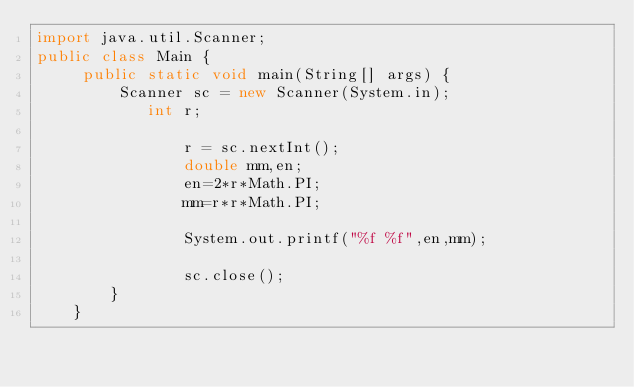<code> <loc_0><loc_0><loc_500><loc_500><_Java_>import java.util.Scanner;
public class Main {
	 public static void main(String[] args) {
		 Scanner sc = new Scanner(System.in);
	        int r;

	            r = sc.nextInt();
	            double mm,en;
	            en=2*r*Math.PI;
	            mm=r*r*Math.PI;
	            
	            System.out.printf("%f %f",en,mm);
	           
	            sc.close();
	    }
	}
</code> 